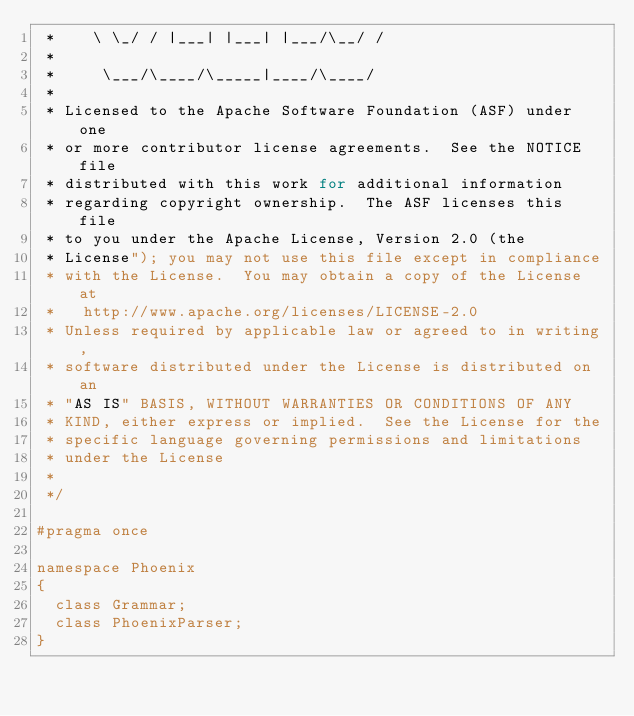<code> <loc_0><loc_0><loc_500><loc_500><_C_> *    \ \_/ / |___| |___| |___/\__/ /
 *
 *     \___/\____/\_____|____/\____/
 *
 * Licensed to the Apache Software Foundation (ASF) under one
 * or more contributor license agreements.  See the NOTICE file
 * distributed with this work for additional information
 * regarding copyright ownership.  The ASF licenses this file
 * to you under the Apache License, Version 2.0 (the
 * License"); you may not use this file except in compliance
 * with the License.  You may obtain a copy of the License at
 *   http://www.apache.org/licenses/LICENSE-2.0
 * Unless required by applicable law or agreed to in writing,
 * software distributed under the License is distributed on an
 * "AS IS" BASIS, WITHOUT WARRANTIES OR CONDITIONS OF ANY
 * KIND, either express or implied.  See the License for the
 * specific language governing permissions and limitations
 * under the License
 *
 */

#pragma once

namespace Phoenix
{
	class Grammar;
	class PhoenixParser;
}
</code> 